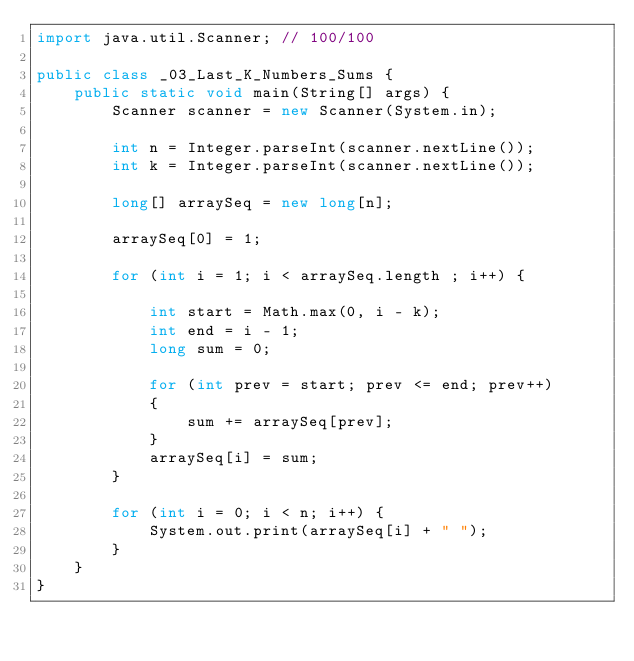Convert code to text. <code><loc_0><loc_0><loc_500><loc_500><_Java_>import java.util.Scanner; // 100/100

public class _03_Last_K_Numbers_Sums {
    public static void main(String[] args) {
        Scanner scanner = new Scanner(System.in);

        int n = Integer.parseInt(scanner.nextLine());
        int k = Integer.parseInt(scanner.nextLine());

        long[] arraySeq = new long[n];

        arraySeq[0] = 1;

        for (int i = 1; i < arraySeq.length ; i++) {

            int start = Math.max(0, i - k);
            int end = i - 1;
            long sum = 0;

            for (int prev = start; prev <= end; prev++)
            {
                sum += arraySeq[prev];
            }
            arraySeq[i] = sum;
        }

        for (int i = 0; i < n; i++) {
            System.out.print(arraySeq[i] + " ");
        }
    }
}
</code> 